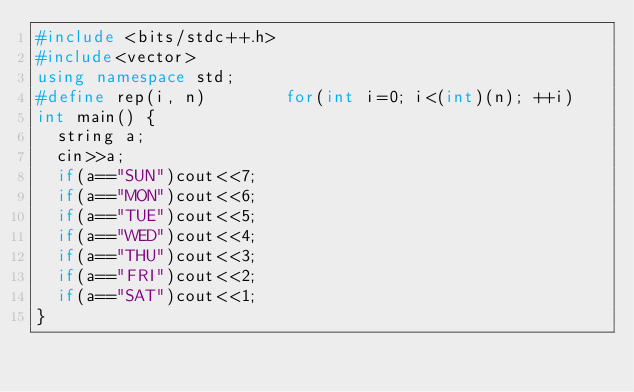<code> <loc_0><loc_0><loc_500><loc_500><_C++_>#include <bits/stdc++.h>
#include<vector>
using namespace std;
#define rep(i, n)        for(int i=0; i<(int)(n); ++i)
int main() {
  string a;
  cin>>a;
  if(a=="SUN")cout<<7;
  if(a=="MON")cout<<6;
  if(a=="TUE")cout<<5;
  if(a=="WED")cout<<4;
  if(a=="THU")cout<<3;
  if(a=="FRI")cout<<2;
  if(a=="SAT")cout<<1;
}
</code> 